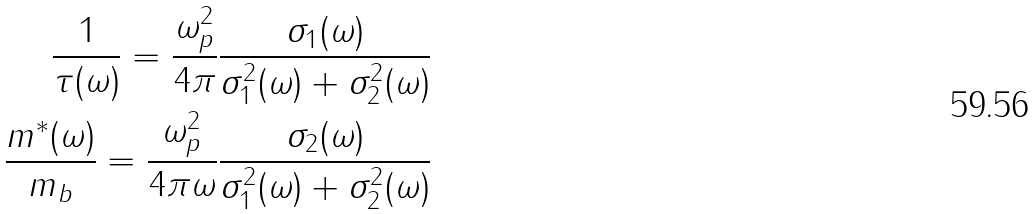Convert formula to latex. <formula><loc_0><loc_0><loc_500><loc_500>\frac { 1 } { \tau ( \omega ) } = \frac { \omega _ { p } ^ { 2 } } { 4 \pi } \frac { \sigma _ { 1 } ( \omega ) } { \sigma _ { 1 } ^ { 2 } ( \omega ) + \sigma _ { 2 } ^ { 2 } ( \omega ) } \\ \frac { m ^ { * } ( \omega ) } { m _ { b } } = \frac { \omega _ { p } ^ { 2 } } { 4 \pi \omega } \frac { \sigma _ { 2 } ( \omega ) } { \sigma _ { 1 } ^ { 2 } ( \omega ) + \sigma _ { 2 } ^ { 2 } ( \omega ) }</formula> 